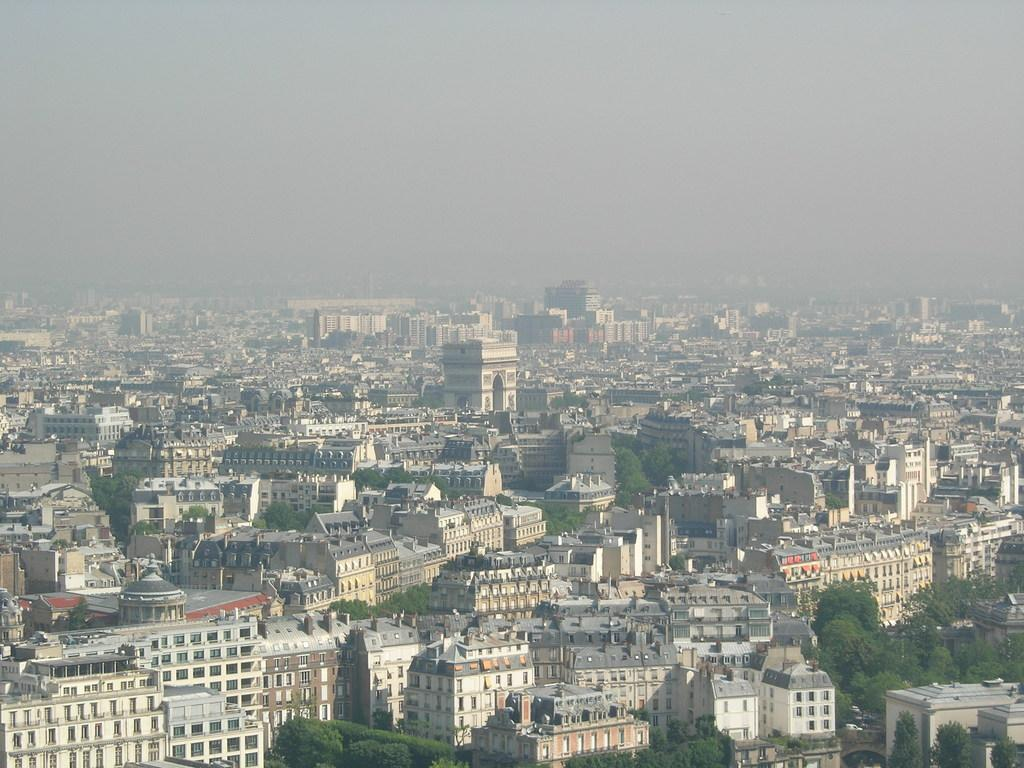What type of structures can be seen in the image? There are buildings in the image. What other natural elements are present in the image? There are trees in the image. What can be seen in the sky in the image? There are clouds in the sky in the sky. Where is the calendar located in the image? There is no calendar present in the image. What type of shelf can be seen in the image? There is no shelf present in the image. 